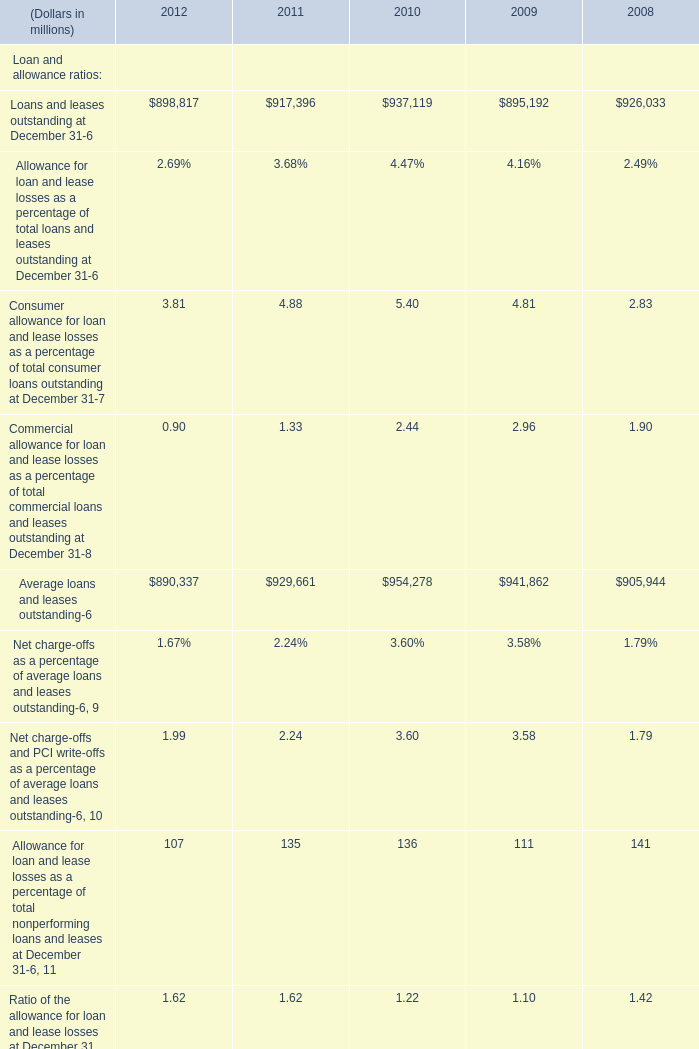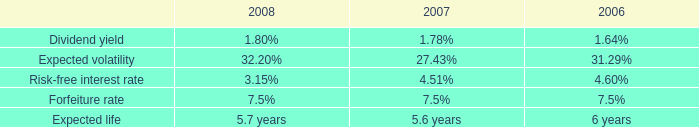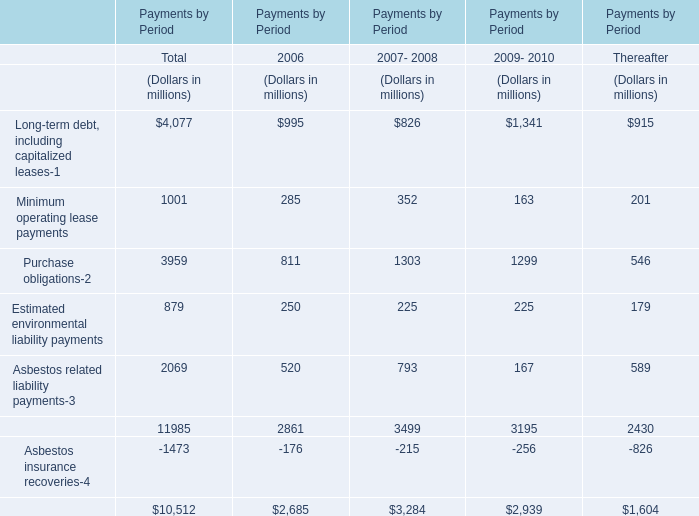What's the sum of Loans and leases outstanding at December 31 and Average loans and leases outstanding in 2012? (in million) 
Computations: (898817 + 890337)
Answer: 1789154.0. 